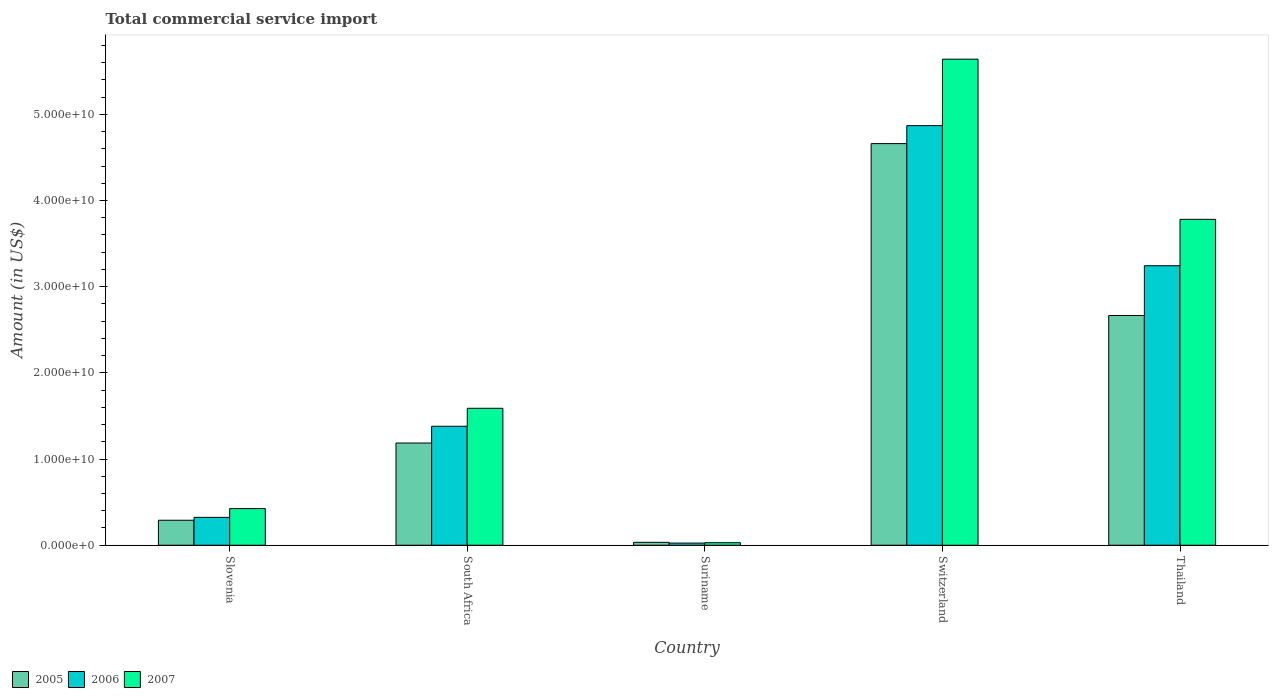How many different coloured bars are there?
Offer a terse response. 3. How many groups of bars are there?
Keep it short and to the point. 5. Are the number of bars on each tick of the X-axis equal?
Keep it short and to the point. Yes. How many bars are there on the 2nd tick from the right?
Keep it short and to the point. 3. What is the label of the 2nd group of bars from the left?
Ensure brevity in your answer.  South Africa. In how many cases, is the number of bars for a given country not equal to the number of legend labels?
Make the answer very short. 0. What is the total commercial service import in 2006 in Suriname?
Give a very brief answer. 2.51e+08. Across all countries, what is the maximum total commercial service import in 2007?
Your answer should be compact. 5.64e+1. Across all countries, what is the minimum total commercial service import in 2006?
Your answer should be compact. 2.51e+08. In which country was the total commercial service import in 2007 maximum?
Offer a terse response. Switzerland. In which country was the total commercial service import in 2007 minimum?
Your response must be concise. Suriname. What is the total total commercial service import in 2006 in the graph?
Offer a terse response. 9.84e+1. What is the difference between the total commercial service import in 2006 in Slovenia and that in South Africa?
Keep it short and to the point. -1.06e+1. What is the difference between the total commercial service import in 2005 in Switzerland and the total commercial service import in 2006 in South Africa?
Ensure brevity in your answer.  3.28e+1. What is the average total commercial service import in 2007 per country?
Your response must be concise. 2.29e+1. What is the difference between the total commercial service import of/in 2005 and total commercial service import of/in 2007 in Slovenia?
Provide a short and direct response. -1.35e+09. What is the ratio of the total commercial service import in 2005 in Switzerland to that in Thailand?
Your answer should be compact. 1.75. Is the total commercial service import in 2005 in Slovenia less than that in Suriname?
Your answer should be compact. No. Is the difference between the total commercial service import in 2005 in Suriname and Thailand greater than the difference between the total commercial service import in 2007 in Suriname and Thailand?
Your answer should be compact. Yes. What is the difference between the highest and the second highest total commercial service import in 2005?
Your response must be concise. -1.48e+1. What is the difference between the highest and the lowest total commercial service import in 2007?
Give a very brief answer. 5.61e+1. In how many countries, is the total commercial service import in 2005 greater than the average total commercial service import in 2005 taken over all countries?
Make the answer very short. 2. Is the sum of the total commercial service import in 2005 in South Africa and Switzerland greater than the maximum total commercial service import in 2007 across all countries?
Give a very brief answer. Yes. What does the 1st bar from the left in Thailand represents?
Offer a terse response. 2005. How many bars are there?
Offer a very short reply. 15. Are all the bars in the graph horizontal?
Provide a short and direct response. No. What is the difference between two consecutive major ticks on the Y-axis?
Your answer should be compact. 1.00e+1. Where does the legend appear in the graph?
Provide a short and direct response. Bottom left. How are the legend labels stacked?
Provide a short and direct response. Horizontal. What is the title of the graph?
Give a very brief answer. Total commercial service import. Does "2003" appear as one of the legend labels in the graph?
Your answer should be very brief. No. What is the label or title of the X-axis?
Offer a very short reply. Country. What is the Amount (in US$) of 2005 in Slovenia?
Give a very brief answer. 2.90e+09. What is the Amount (in US$) in 2006 in Slovenia?
Your answer should be compact. 3.24e+09. What is the Amount (in US$) in 2007 in Slovenia?
Offer a terse response. 4.25e+09. What is the Amount (in US$) of 2005 in South Africa?
Provide a succinct answer. 1.19e+1. What is the Amount (in US$) of 2006 in South Africa?
Your answer should be very brief. 1.38e+1. What is the Amount (in US$) of 2007 in South Africa?
Give a very brief answer. 1.59e+1. What is the Amount (in US$) of 2005 in Suriname?
Give a very brief answer. 3.39e+08. What is the Amount (in US$) of 2006 in Suriname?
Make the answer very short. 2.51e+08. What is the Amount (in US$) in 2007 in Suriname?
Your answer should be compact. 2.93e+08. What is the Amount (in US$) of 2005 in Switzerland?
Provide a succinct answer. 4.66e+1. What is the Amount (in US$) of 2006 in Switzerland?
Your answer should be very brief. 4.87e+1. What is the Amount (in US$) in 2007 in Switzerland?
Your response must be concise. 5.64e+1. What is the Amount (in US$) in 2005 in Thailand?
Ensure brevity in your answer.  2.67e+1. What is the Amount (in US$) of 2006 in Thailand?
Ensure brevity in your answer.  3.24e+1. What is the Amount (in US$) in 2007 in Thailand?
Your answer should be very brief. 3.78e+1. Across all countries, what is the maximum Amount (in US$) of 2005?
Your answer should be compact. 4.66e+1. Across all countries, what is the maximum Amount (in US$) in 2006?
Provide a succinct answer. 4.87e+1. Across all countries, what is the maximum Amount (in US$) of 2007?
Your answer should be very brief. 5.64e+1. Across all countries, what is the minimum Amount (in US$) of 2005?
Ensure brevity in your answer.  3.39e+08. Across all countries, what is the minimum Amount (in US$) in 2006?
Your answer should be very brief. 2.51e+08. Across all countries, what is the minimum Amount (in US$) of 2007?
Give a very brief answer. 2.93e+08. What is the total Amount (in US$) in 2005 in the graph?
Your answer should be very brief. 8.84e+1. What is the total Amount (in US$) in 2006 in the graph?
Make the answer very short. 9.84e+1. What is the total Amount (in US$) in 2007 in the graph?
Provide a short and direct response. 1.15e+11. What is the difference between the Amount (in US$) in 2005 in Slovenia and that in South Africa?
Provide a succinct answer. -8.96e+09. What is the difference between the Amount (in US$) of 2006 in Slovenia and that in South Africa?
Offer a very short reply. -1.06e+1. What is the difference between the Amount (in US$) of 2007 in Slovenia and that in South Africa?
Ensure brevity in your answer.  -1.16e+1. What is the difference between the Amount (in US$) of 2005 in Slovenia and that in Suriname?
Offer a very short reply. 2.56e+09. What is the difference between the Amount (in US$) in 2006 in Slovenia and that in Suriname?
Your response must be concise. 2.98e+09. What is the difference between the Amount (in US$) of 2007 in Slovenia and that in Suriname?
Provide a succinct answer. 3.96e+09. What is the difference between the Amount (in US$) of 2005 in Slovenia and that in Switzerland?
Offer a very short reply. -4.37e+1. What is the difference between the Amount (in US$) of 2006 in Slovenia and that in Switzerland?
Your answer should be compact. -4.55e+1. What is the difference between the Amount (in US$) of 2007 in Slovenia and that in Switzerland?
Give a very brief answer. -5.21e+1. What is the difference between the Amount (in US$) in 2005 in Slovenia and that in Thailand?
Make the answer very short. -2.38e+1. What is the difference between the Amount (in US$) in 2006 in Slovenia and that in Thailand?
Offer a terse response. -2.92e+1. What is the difference between the Amount (in US$) of 2007 in Slovenia and that in Thailand?
Offer a very short reply. -3.36e+1. What is the difference between the Amount (in US$) in 2005 in South Africa and that in Suriname?
Give a very brief answer. 1.15e+1. What is the difference between the Amount (in US$) in 2006 in South Africa and that in Suriname?
Your answer should be very brief. 1.36e+1. What is the difference between the Amount (in US$) of 2007 in South Africa and that in Suriname?
Your answer should be compact. 1.56e+1. What is the difference between the Amount (in US$) in 2005 in South Africa and that in Switzerland?
Your answer should be compact. -3.47e+1. What is the difference between the Amount (in US$) in 2006 in South Africa and that in Switzerland?
Provide a short and direct response. -3.49e+1. What is the difference between the Amount (in US$) in 2007 in South Africa and that in Switzerland?
Your response must be concise. -4.05e+1. What is the difference between the Amount (in US$) of 2005 in South Africa and that in Thailand?
Provide a succinct answer. -1.48e+1. What is the difference between the Amount (in US$) of 2006 in South Africa and that in Thailand?
Provide a succinct answer. -1.86e+1. What is the difference between the Amount (in US$) in 2007 in South Africa and that in Thailand?
Your answer should be very brief. -2.19e+1. What is the difference between the Amount (in US$) of 2005 in Suriname and that in Switzerland?
Keep it short and to the point. -4.63e+1. What is the difference between the Amount (in US$) in 2006 in Suriname and that in Switzerland?
Ensure brevity in your answer.  -4.84e+1. What is the difference between the Amount (in US$) in 2007 in Suriname and that in Switzerland?
Your answer should be very brief. -5.61e+1. What is the difference between the Amount (in US$) of 2005 in Suriname and that in Thailand?
Give a very brief answer. -2.63e+1. What is the difference between the Amount (in US$) in 2006 in Suriname and that in Thailand?
Give a very brief answer. -3.22e+1. What is the difference between the Amount (in US$) of 2007 in Suriname and that in Thailand?
Provide a short and direct response. -3.75e+1. What is the difference between the Amount (in US$) of 2005 in Switzerland and that in Thailand?
Offer a terse response. 1.99e+1. What is the difference between the Amount (in US$) in 2006 in Switzerland and that in Thailand?
Provide a succinct answer. 1.63e+1. What is the difference between the Amount (in US$) in 2007 in Switzerland and that in Thailand?
Provide a succinct answer. 1.86e+1. What is the difference between the Amount (in US$) of 2005 in Slovenia and the Amount (in US$) of 2006 in South Africa?
Your answer should be compact. -1.09e+1. What is the difference between the Amount (in US$) in 2005 in Slovenia and the Amount (in US$) in 2007 in South Africa?
Offer a very short reply. -1.30e+1. What is the difference between the Amount (in US$) in 2006 in Slovenia and the Amount (in US$) in 2007 in South Africa?
Offer a very short reply. -1.27e+1. What is the difference between the Amount (in US$) in 2005 in Slovenia and the Amount (in US$) in 2006 in Suriname?
Provide a short and direct response. 2.65e+09. What is the difference between the Amount (in US$) of 2005 in Slovenia and the Amount (in US$) of 2007 in Suriname?
Offer a very short reply. 2.61e+09. What is the difference between the Amount (in US$) in 2006 in Slovenia and the Amount (in US$) in 2007 in Suriname?
Provide a succinct answer. 2.94e+09. What is the difference between the Amount (in US$) of 2005 in Slovenia and the Amount (in US$) of 2006 in Switzerland?
Provide a succinct answer. -4.58e+1. What is the difference between the Amount (in US$) of 2005 in Slovenia and the Amount (in US$) of 2007 in Switzerland?
Offer a terse response. -5.35e+1. What is the difference between the Amount (in US$) of 2006 in Slovenia and the Amount (in US$) of 2007 in Switzerland?
Your response must be concise. -5.32e+1. What is the difference between the Amount (in US$) of 2005 in Slovenia and the Amount (in US$) of 2006 in Thailand?
Ensure brevity in your answer.  -2.95e+1. What is the difference between the Amount (in US$) in 2005 in Slovenia and the Amount (in US$) in 2007 in Thailand?
Provide a succinct answer. -3.49e+1. What is the difference between the Amount (in US$) of 2006 in Slovenia and the Amount (in US$) of 2007 in Thailand?
Your answer should be compact. -3.46e+1. What is the difference between the Amount (in US$) in 2005 in South Africa and the Amount (in US$) in 2006 in Suriname?
Offer a very short reply. 1.16e+1. What is the difference between the Amount (in US$) in 2005 in South Africa and the Amount (in US$) in 2007 in Suriname?
Your answer should be very brief. 1.16e+1. What is the difference between the Amount (in US$) of 2006 in South Africa and the Amount (in US$) of 2007 in Suriname?
Give a very brief answer. 1.35e+1. What is the difference between the Amount (in US$) in 2005 in South Africa and the Amount (in US$) in 2006 in Switzerland?
Provide a succinct answer. -3.68e+1. What is the difference between the Amount (in US$) in 2005 in South Africa and the Amount (in US$) in 2007 in Switzerland?
Provide a succinct answer. -4.45e+1. What is the difference between the Amount (in US$) of 2006 in South Africa and the Amount (in US$) of 2007 in Switzerland?
Provide a succinct answer. -4.26e+1. What is the difference between the Amount (in US$) in 2005 in South Africa and the Amount (in US$) in 2006 in Thailand?
Your answer should be compact. -2.06e+1. What is the difference between the Amount (in US$) in 2005 in South Africa and the Amount (in US$) in 2007 in Thailand?
Offer a very short reply. -2.60e+1. What is the difference between the Amount (in US$) in 2006 in South Africa and the Amount (in US$) in 2007 in Thailand?
Ensure brevity in your answer.  -2.40e+1. What is the difference between the Amount (in US$) in 2005 in Suriname and the Amount (in US$) in 2006 in Switzerland?
Offer a very short reply. -4.83e+1. What is the difference between the Amount (in US$) in 2005 in Suriname and the Amount (in US$) in 2007 in Switzerland?
Make the answer very short. -5.61e+1. What is the difference between the Amount (in US$) in 2006 in Suriname and the Amount (in US$) in 2007 in Switzerland?
Provide a succinct answer. -5.61e+1. What is the difference between the Amount (in US$) of 2005 in Suriname and the Amount (in US$) of 2006 in Thailand?
Ensure brevity in your answer.  -3.21e+1. What is the difference between the Amount (in US$) of 2005 in Suriname and the Amount (in US$) of 2007 in Thailand?
Offer a very short reply. -3.75e+1. What is the difference between the Amount (in US$) of 2006 in Suriname and the Amount (in US$) of 2007 in Thailand?
Make the answer very short. -3.76e+1. What is the difference between the Amount (in US$) in 2005 in Switzerland and the Amount (in US$) in 2006 in Thailand?
Make the answer very short. 1.42e+1. What is the difference between the Amount (in US$) in 2005 in Switzerland and the Amount (in US$) in 2007 in Thailand?
Provide a succinct answer. 8.79e+09. What is the difference between the Amount (in US$) of 2006 in Switzerland and the Amount (in US$) of 2007 in Thailand?
Offer a terse response. 1.09e+1. What is the average Amount (in US$) in 2005 per country?
Your answer should be very brief. 1.77e+1. What is the average Amount (in US$) of 2006 per country?
Give a very brief answer. 1.97e+1. What is the average Amount (in US$) of 2007 per country?
Offer a very short reply. 2.29e+1. What is the difference between the Amount (in US$) in 2005 and Amount (in US$) in 2006 in Slovenia?
Provide a succinct answer. -3.36e+08. What is the difference between the Amount (in US$) in 2005 and Amount (in US$) in 2007 in Slovenia?
Offer a very short reply. -1.35e+09. What is the difference between the Amount (in US$) of 2006 and Amount (in US$) of 2007 in Slovenia?
Make the answer very short. -1.02e+09. What is the difference between the Amount (in US$) in 2005 and Amount (in US$) in 2006 in South Africa?
Give a very brief answer. -1.94e+09. What is the difference between the Amount (in US$) of 2005 and Amount (in US$) of 2007 in South Africa?
Make the answer very short. -4.03e+09. What is the difference between the Amount (in US$) in 2006 and Amount (in US$) in 2007 in South Africa?
Make the answer very short. -2.09e+09. What is the difference between the Amount (in US$) of 2005 and Amount (in US$) of 2006 in Suriname?
Ensure brevity in your answer.  8.83e+07. What is the difference between the Amount (in US$) of 2005 and Amount (in US$) of 2007 in Suriname?
Give a very brief answer. 4.63e+07. What is the difference between the Amount (in US$) of 2006 and Amount (in US$) of 2007 in Suriname?
Your response must be concise. -4.20e+07. What is the difference between the Amount (in US$) in 2005 and Amount (in US$) in 2006 in Switzerland?
Your answer should be compact. -2.09e+09. What is the difference between the Amount (in US$) of 2005 and Amount (in US$) of 2007 in Switzerland?
Ensure brevity in your answer.  -9.80e+09. What is the difference between the Amount (in US$) of 2006 and Amount (in US$) of 2007 in Switzerland?
Your response must be concise. -7.71e+09. What is the difference between the Amount (in US$) in 2005 and Amount (in US$) in 2006 in Thailand?
Offer a terse response. -5.77e+09. What is the difference between the Amount (in US$) of 2005 and Amount (in US$) of 2007 in Thailand?
Provide a short and direct response. -1.12e+1. What is the difference between the Amount (in US$) of 2006 and Amount (in US$) of 2007 in Thailand?
Give a very brief answer. -5.38e+09. What is the ratio of the Amount (in US$) in 2005 in Slovenia to that in South Africa?
Your answer should be very brief. 0.24. What is the ratio of the Amount (in US$) in 2006 in Slovenia to that in South Africa?
Make the answer very short. 0.23. What is the ratio of the Amount (in US$) in 2007 in Slovenia to that in South Africa?
Give a very brief answer. 0.27. What is the ratio of the Amount (in US$) of 2005 in Slovenia to that in Suriname?
Keep it short and to the point. 8.55. What is the ratio of the Amount (in US$) of 2006 in Slovenia to that in Suriname?
Your answer should be compact. 12.9. What is the ratio of the Amount (in US$) of 2007 in Slovenia to that in Suriname?
Give a very brief answer. 14.52. What is the ratio of the Amount (in US$) in 2005 in Slovenia to that in Switzerland?
Offer a terse response. 0.06. What is the ratio of the Amount (in US$) of 2006 in Slovenia to that in Switzerland?
Your response must be concise. 0.07. What is the ratio of the Amount (in US$) in 2007 in Slovenia to that in Switzerland?
Give a very brief answer. 0.08. What is the ratio of the Amount (in US$) of 2005 in Slovenia to that in Thailand?
Provide a succinct answer. 0.11. What is the ratio of the Amount (in US$) of 2006 in Slovenia to that in Thailand?
Offer a very short reply. 0.1. What is the ratio of the Amount (in US$) of 2007 in Slovenia to that in Thailand?
Give a very brief answer. 0.11. What is the ratio of the Amount (in US$) in 2005 in South Africa to that in Suriname?
Offer a very short reply. 34.96. What is the ratio of the Amount (in US$) in 2006 in South Africa to that in Suriname?
Your answer should be very brief. 55.01. What is the ratio of the Amount (in US$) in 2007 in South Africa to that in Suriname?
Offer a terse response. 54.25. What is the ratio of the Amount (in US$) in 2005 in South Africa to that in Switzerland?
Provide a succinct answer. 0.25. What is the ratio of the Amount (in US$) of 2006 in South Africa to that in Switzerland?
Provide a succinct answer. 0.28. What is the ratio of the Amount (in US$) in 2007 in South Africa to that in Switzerland?
Your answer should be compact. 0.28. What is the ratio of the Amount (in US$) in 2005 in South Africa to that in Thailand?
Keep it short and to the point. 0.44. What is the ratio of the Amount (in US$) in 2006 in South Africa to that in Thailand?
Your answer should be compact. 0.43. What is the ratio of the Amount (in US$) of 2007 in South Africa to that in Thailand?
Your answer should be very brief. 0.42. What is the ratio of the Amount (in US$) of 2005 in Suriname to that in Switzerland?
Your response must be concise. 0.01. What is the ratio of the Amount (in US$) of 2006 in Suriname to that in Switzerland?
Your answer should be compact. 0.01. What is the ratio of the Amount (in US$) of 2007 in Suriname to that in Switzerland?
Your answer should be very brief. 0.01. What is the ratio of the Amount (in US$) of 2005 in Suriname to that in Thailand?
Offer a very short reply. 0.01. What is the ratio of the Amount (in US$) in 2006 in Suriname to that in Thailand?
Keep it short and to the point. 0.01. What is the ratio of the Amount (in US$) of 2007 in Suriname to that in Thailand?
Your response must be concise. 0.01. What is the ratio of the Amount (in US$) in 2005 in Switzerland to that in Thailand?
Offer a very short reply. 1.75. What is the ratio of the Amount (in US$) of 2006 in Switzerland to that in Thailand?
Give a very brief answer. 1.5. What is the ratio of the Amount (in US$) of 2007 in Switzerland to that in Thailand?
Keep it short and to the point. 1.49. What is the difference between the highest and the second highest Amount (in US$) in 2005?
Provide a succinct answer. 1.99e+1. What is the difference between the highest and the second highest Amount (in US$) of 2006?
Give a very brief answer. 1.63e+1. What is the difference between the highest and the second highest Amount (in US$) of 2007?
Offer a very short reply. 1.86e+1. What is the difference between the highest and the lowest Amount (in US$) in 2005?
Give a very brief answer. 4.63e+1. What is the difference between the highest and the lowest Amount (in US$) of 2006?
Make the answer very short. 4.84e+1. What is the difference between the highest and the lowest Amount (in US$) of 2007?
Your answer should be compact. 5.61e+1. 